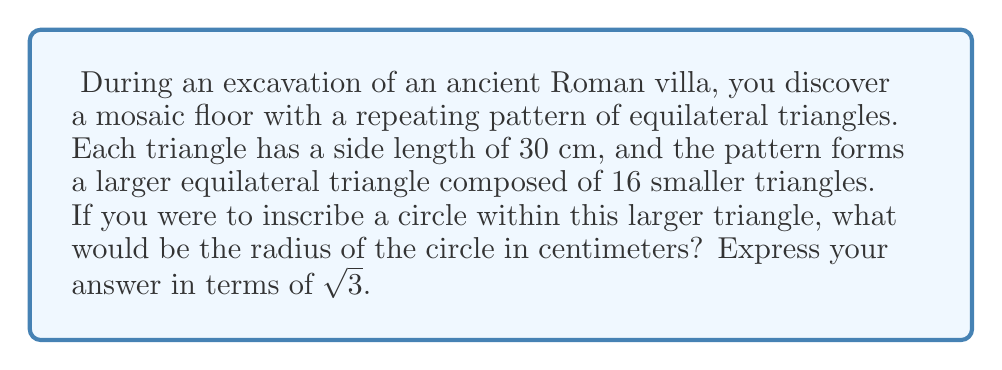Give your solution to this math problem. Let's approach this step-by-step:

1) First, we need to find the side length of the larger triangle. Since it's composed of 4 smaller triangles on each side, the side length is:

   $S = 4 \times 30 = 120$ cm

2) In an equilateral triangle, the radius of an inscribed circle is given by the formula:

   $r = \frac{a}{2\sqrt{3}}$

   where $a$ is the side length of the triangle.

3) Substituting our side length into this formula:

   $r = \frac{120}{2\sqrt{3}} = \frac{60}{\sqrt{3}}$ cm

4) To simplify this, we can rationalize the denominator:

   $r = \frac{60}{\sqrt{3}} \cdot \frac{\sqrt{3}}{\sqrt{3}} = \frac{60\sqrt{3}}{3} = 20\sqrt{3}$ cm

Therefore, the radius of the inscribed circle is $20\sqrt{3}$ cm.
Answer: $20\sqrt{3}$ cm 